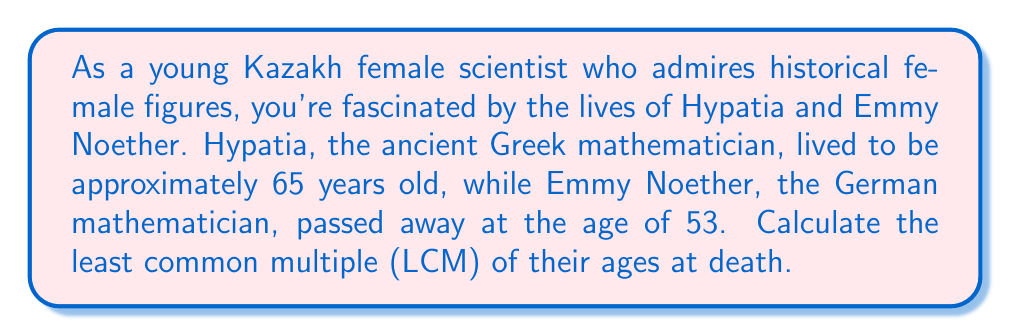Show me your answer to this math problem. To find the least common multiple (LCM) of 65 and 53, we'll follow these steps:

1. First, let's find the prime factorization of both numbers:

   $65 = 5 \times 13$
   $53$ is already a prime number

2. The LCM will include the highest power of each prime factor from either number. In this case:
   - We need one 5 from 65
   - We need one 13 from 65
   - We need one 53 from 53

3. Now, we multiply these factors:

   $LCM(65, 53) = 5 \times 13 \times 53$

4. Let's calculate this:
   
   $LCM(65, 53) = 5 \times 13 \times 53 = 3445$

Therefore, the least common multiple of Hypatia's and Emmy Noether's ages at death is 3445.

This problem connects number theory with the lives of two remarkable female mathematicians, highlighting the interdisciplinary nature of mathematical thinking and its connection to history.
Answer: $3445$ 